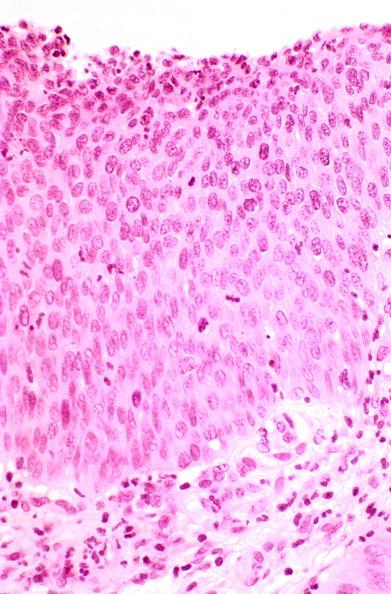what is present?
Answer the question using a single word or phrase. Female reproductive 